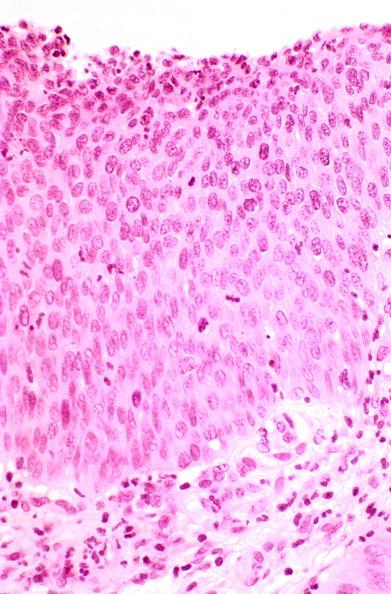what is present?
Answer the question using a single word or phrase. Female reproductive 